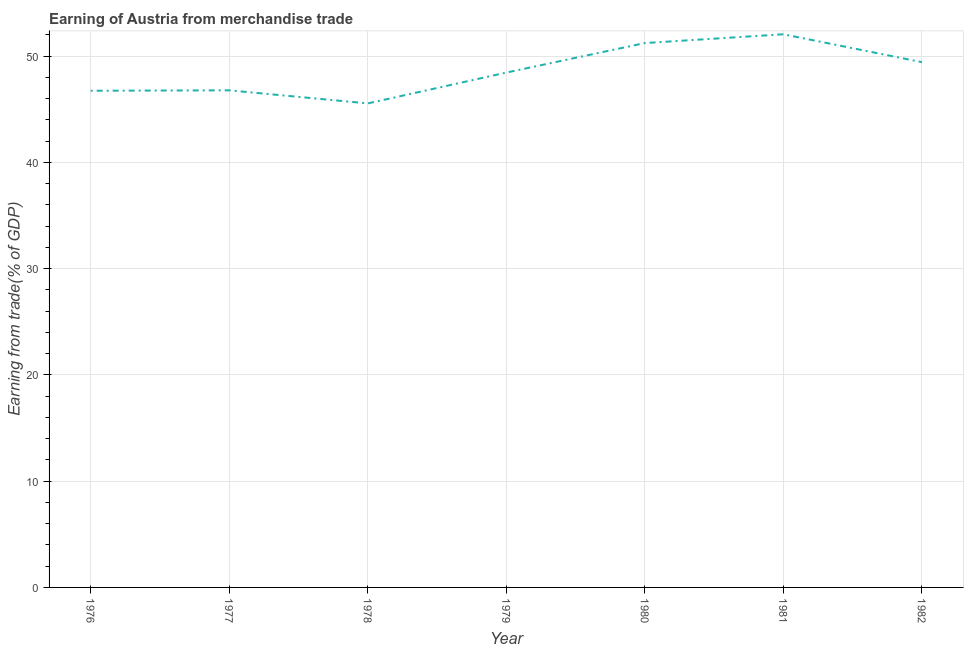What is the earning from merchandise trade in 1978?
Ensure brevity in your answer.  45.54. Across all years, what is the maximum earning from merchandise trade?
Your answer should be very brief. 52.05. Across all years, what is the minimum earning from merchandise trade?
Your answer should be compact. 45.54. In which year was the earning from merchandise trade maximum?
Your response must be concise. 1981. In which year was the earning from merchandise trade minimum?
Your response must be concise. 1978. What is the sum of the earning from merchandise trade?
Make the answer very short. 340.2. What is the difference between the earning from merchandise trade in 1976 and 1980?
Offer a terse response. -4.49. What is the average earning from merchandise trade per year?
Ensure brevity in your answer.  48.6. What is the median earning from merchandise trade?
Offer a very short reply. 48.45. In how many years, is the earning from merchandise trade greater than 28 %?
Your response must be concise. 7. What is the ratio of the earning from merchandise trade in 1978 to that in 1982?
Your response must be concise. 0.92. What is the difference between the highest and the second highest earning from merchandise trade?
Give a very brief answer. 0.83. Is the sum of the earning from merchandise trade in 1977 and 1982 greater than the maximum earning from merchandise trade across all years?
Your answer should be compact. Yes. What is the difference between the highest and the lowest earning from merchandise trade?
Offer a terse response. 6.5. What is the difference between two consecutive major ticks on the Y-axis?
Give a very brief answer. 10. Does the graph contain any zero values?
Provide a succinct answer. No. What is the title of the graph?
Offer a terse response. Earning of Austria from merchandise trade. What is the label or title of the X-axis?
Make the answer very short. Year. What is the label or title of the Y-axis?
Make the answer very short. Earning from trade(% of GDP). What is the Earning from trade(% of GDP) of 1976?
Ensure brevity in your answer.  46.74. What is the Earning from trade(% of GDP) of 1977?
Ensure brevity in your answer.  46.78. What is the Earning from trade(% of GDP) in 1978?
Your response must be concise. 45.54. What is the Earning from trade(% of GDP) of 1979?
Your answer should be compact. 48.45. What is the Earning from trade(% of GDP) in 1980?
Your answer should be very brief. 51.22. What is the Earning from trade(% of GDP) of 1981?
Make the answer very short. 52.05. What is the Earning from trade(% of GDP) in 1982?
Offer a very short reply. 49.43. What is the difference between the Earning from trade(% of GDP) in 1976 and 1977?
Your answer should be compact. -0.04. What is the difference between the Earning from trade(% of GDP) in 1976 and 1978?
Your answer should be very brief. 1.19. What is the difference between the Earning from trade(% of GDP) in 1976 and 1979?
Your answer should be compact. -1.71. What is the difference between the Earning from trade(% of GDP) in 1976 and 1980?
Provide a succinct answer. -4.49. What is the difference between the Earning from trade(% of GDP) in 1976 and 1981?
Offer a terse response. -5.31. What is the difference between the Earning from trade(% of GDP) in 1976 and 1982?
Make the answer very short. -2.69. What is the difference between the Earning from trade(% of GDP) in 1977 and 1978?
Make the answer very short. 1.23. What is the difference between the Earning from trade(% of GDP) in 1977 and 1979?
Give a very brief answer. -1.67. What is the difference between the Earning from trade(% of GDP) in 1977 and 1980?
Your answer should be compact. -4.45. What is the difference between the Earning from trade(% of GDP) in 1977 and 1981?
Your answer should be compact. -5.27. What is the difference between the Earning from trade(% of GDP) in 1977 and 1982?
Your answer should be compact. -2.65. What is the difference between the Earning from trade(% of GDP) in 1978 and 1979?
Provide a succinct answer. -2.9. What is the difference between the Earning from trade(% of GDP) in 1978 and 1980?
Offer a very short reply. -5.68. What is the difference between the Earning from trade(% of GDP) in 1978 and 1981?
Ensure brevity in your answer.  -6.5. What is the difference between the Earning from trade(% of GDP) in 1978 and 1982?
Your response must be concise. -3.88. What is the difference between the Earning from trade(% of GDP) in 1979 and 1980?
Ensure brevity in your answer.  -2.78. What is the difference between the Earning from trade(% of GDP) in 1979 and 1981?
Provide a succinct answer. -3.6. What is the difference between the Earning from trade(% of GDP) in 1979 and 1982?
Provide a short and direct response. -0.98. What is the difference between the Earning from trade(% of GDP) in 1980 and 1981?
Keep it short and to the point. -0.83. What is the difference between the Earning from trade(% of GDP) in 1980 and 1982?
Make the answer very short. 1.8. What is the difference between the Earning from trade(% of GDP) in 1981 and 1982?
Your answer should be very brief. 2.62. What is the ratio of the Earning from trade(% of GDP) in 1976 to that in 1977?
Offer a very short reply. 1. What is the ratio of the Earning from trade(% of GDP) in 1976 to that in 1980?
Offer a terse response. 0.91. What is the ratio of the Earning from trade(% of GDP) in 1976 to that in 1981?
Make the answer very short. 0.9. What is the ratio of the Earning from trade(% of GDP) in 1976 to that in 1982?
Your answer should be very brief. 0.95. What is the ratio of the Earning from trade(% of GDP) in 1977 to that in 1978?
Ensure brevity in your answer.  1.03. What is the ratio of the Earning from trade(% of GDP) in 1977 to that in 1979?
Ensure brevity in your answer.  0.97. What is the ratio of the Earning from trade(% of GDP) in 1977 to that in 1981?
Make the answer very short. 0.9. What is the ratio of the Earning from trade(% of GDP) in 1977 to that in 1982?
Provide a short and direct response. 0.95. What is the ratio of the Earning from trade(% of GDP) in 1978 to that in 1980?
Offer a terse response. 0.89. What is the ratio of the Earning from trade(% of GDP) in 1978 to that in 1982?
Ensure brevity in your answer.  0.92. What is the ratio of the Earning from trade(% of GDP) in 1979 to that in 1980?
Provide a succinct answer. 0.95. What is the ratio of the Earning from trade(% of GDP) in 1979 to that in 1981?
Provide a short and direct response. 0.93. What is the ratio of the Earning from trade(% of GDP) in 1979 to that in 1982?
Your response must be concise. 0.98. What is the ratio of the Earning from trade(% of GDP) in 1980 to that in 1981?
Offer a terse response. 0.98. What is the ratio of the Earning from trade(% of GDP) in 1980 to that in 1982?
Keep it short and to the point. 1.04. What is the ratio of the Earning from trade(% of GDP) in 1981 to that in 1982?
Keep it short and to the point. 1.05. 